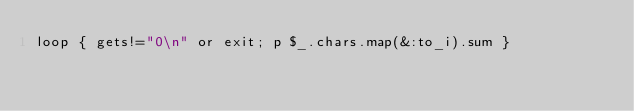<code> <loc_0><loc_0><loc_500><loc_500><_Ruby_>loop { gets!="0\n" or exit; p $_.chars.map(&:to_i).sum }
</code> 